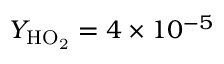<formula> <loc_0><loc_0><loc_500><loc_500>Y _ { H O _ { 2 } } = 4 \times 1 0 ^ { - 5 }</formula> 